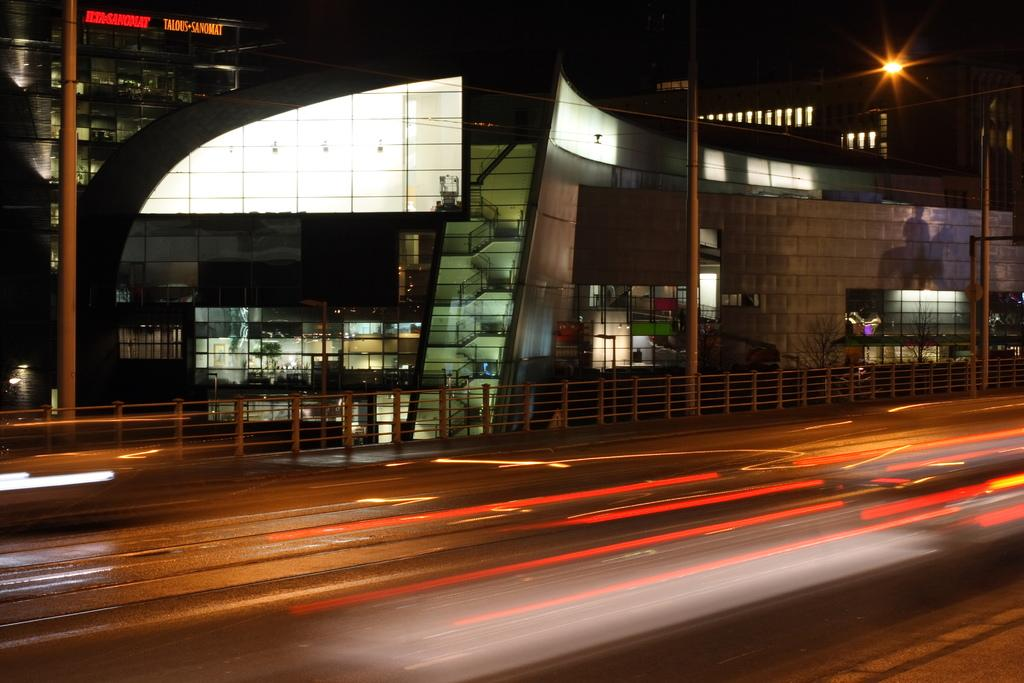What is the main feature of the image? There is a road in the image. What is located beside the road? There is a barricade beside the road. What can be seen in the background of the image? There is a group of buildings with windows in the background. Can you describe any specific details about the buildings? There is a sign board on one of the buildings. What else is visible in the image? There are poles visible in the image, and there are lights on the poles. What is the position of the worm on the road in the image? There is no worm present in the image. 